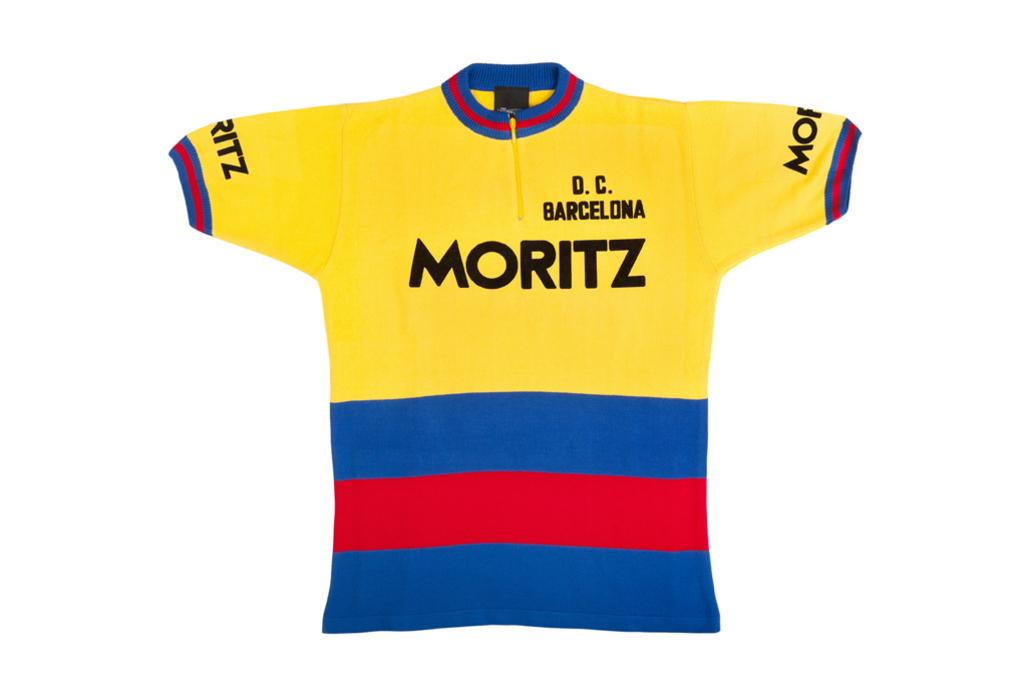<image>
Create a compact narrative representing the image presented. A yellow shirt with blue and red stripes at the bottom and Moritz D.C. Barcelona written on it. 